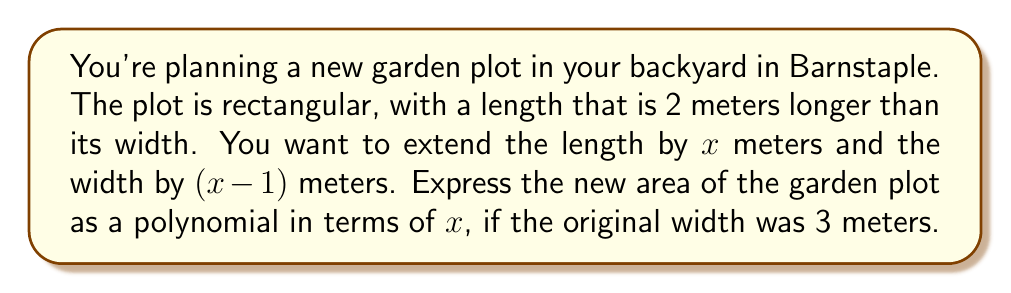Can you answer this question? Let's approach this step-by-step:

1) First, let's identify the original dimensions:
   - Width = 3 meters
   - Length = 3 + 2 = 5 meters (as it's 2 meters longer than the width)

2) Now, let's express the new dimensions after extension:
   - New width = 3 + (x-1) = x + 2 meters
   - New length = 5 + x meters

3) The area of a rectangle is given by length × width. So, the new area will be:
   $$ A = (5 + x)(x + 2) $$

4) Let's expand this expression:
   $$ A = 5x + 10 + x^2 + 2x $$

5) Simplifying by combining like terms:
   $$ A = x^2 + 7x + 10 $$

This polynomial expression represents the new area of the garden plot in square meters, in terms of x.
Answer: $$ A = x^2 + 7x + 10 \text{ square meters} $$ 